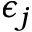<formula> <loc_0><loc_0><loc_500><loc_500>\epsilon _ { j }</formula> 